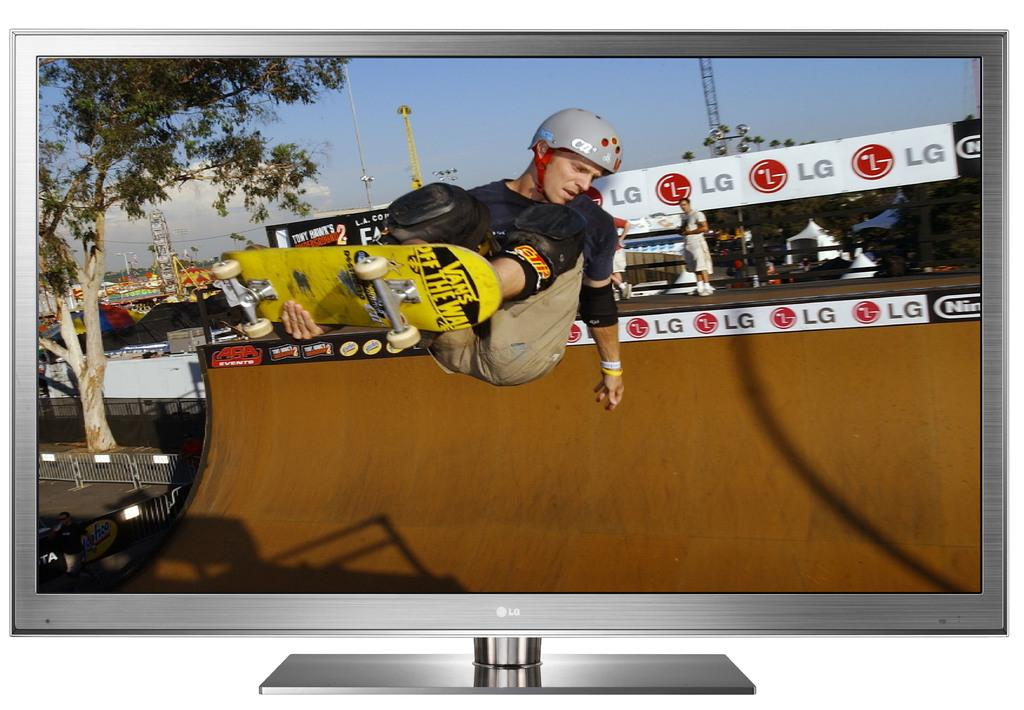<image>
Offer a succinct explanation of the picture presented. A man in a skatepark riding a skateboard that says Vans Off The Wall on the bottom of it. 